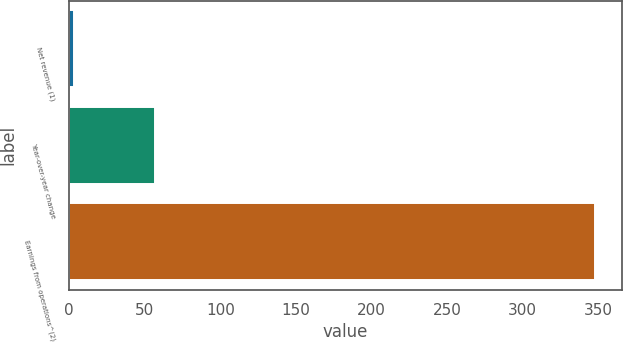Convert chart to OTSL. <chart><loc_0><loc_0><loc_500><loc_500><bar_chart><fcel>Net revenue (1)<fcel>Year-over-year change<fcel>Earnings from operations^(2)<nl><fcel>3<fcel>57.1<fcel>348<nl></chart> 